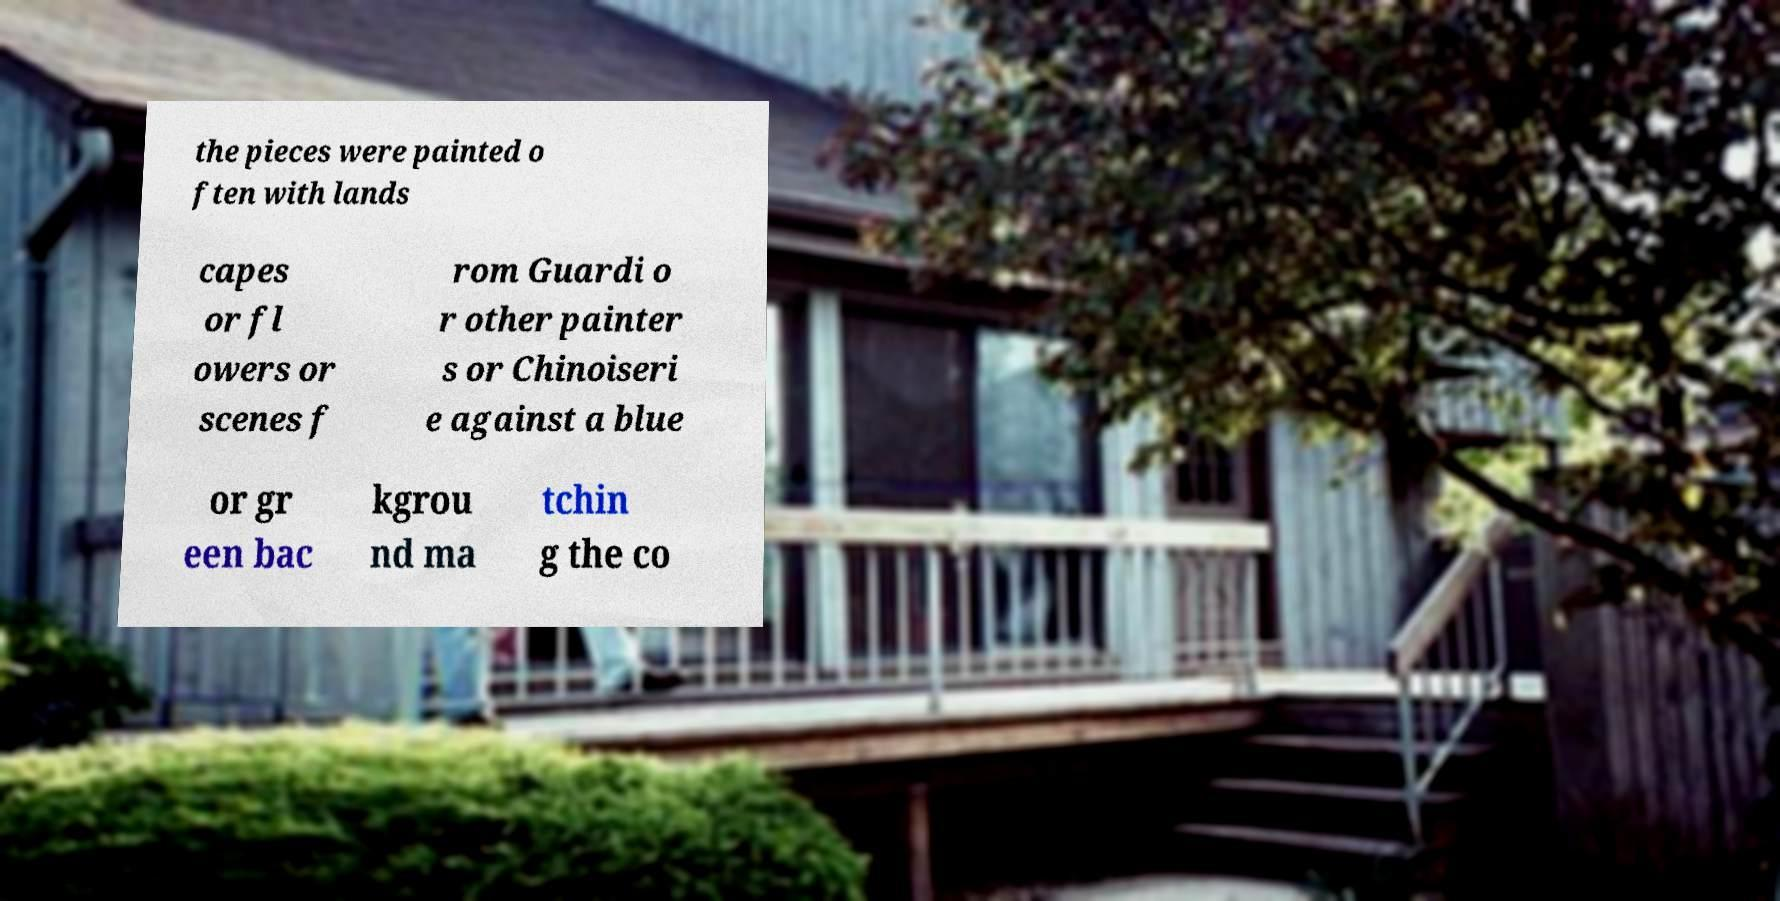Could you assist in decoding the text presented in this image and type it out clearly? the pieces were painted o ften with lands capes or fl owers or scenes f rom Guardi o r other painter s or Chinoiseri e against a blue or gr een bac kgrou nd ma tchin g the co 